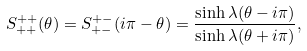<formula> <loc_0><loc_0><loc_500><loc_500>S ^ { + + } _ { + + } ( \theta ) = S ^ { + - } _ { + - } ( i \pi - \theta ) = \frac { \sinh \lambda ( \theta - i \pi ) } { \sinh \lambda ( \theta + i \pi ) } ,</formula> 